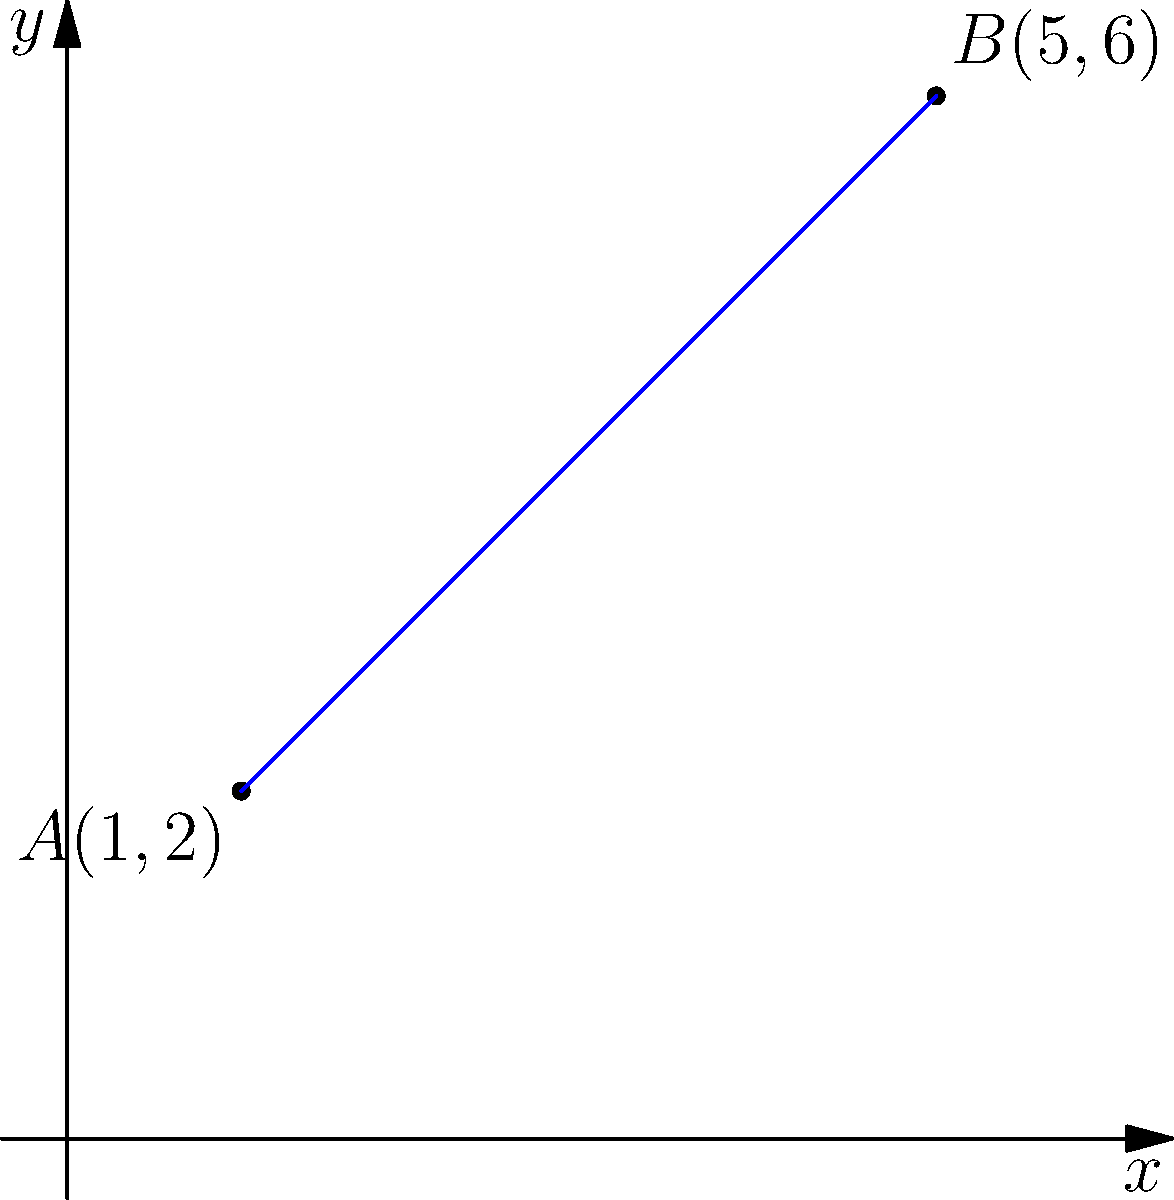In a high-profile legal case, you need to analyze the trajectory of a projectile. Two key points have been identified: point A(1,2) and point B(5,6). Determine the slope of the line passing through these points and formulate its equation in point-slope form. How would this information strengthen your case preparation? To solve this problem, we'll follow these steps:

1. Calculate the slope of the line:
   The slope formula is $m = \frac{y_2 - y_1}{x_2 - x_1}$
   
   $m = \frac{6 - 2}{5 - 1} = \frac{4}{4} = 1$

2. Use the point-slope form of a line:
   The general form is $y - y_1 = m(x - x_1)$
   
   We can use either point. Let's use A(1,2):
   
   $y - 2 = 1(x - 1)$

3. Simplify the equation:
   $y - 2 = x - 1$
   
   This is the point-slope form of the line equation.

This information strengthens the case preparation by:
a) Providing a precise mathematical model of the projectile's path
b) Allowing for accurate predictions of the projectile's position at any given point
c) Enabling the lawyer to challenge or support expert testimony regarding the trajectory
d) Facilitating clear and convincing visual representations for the jury
Answer: Slope: 1; Equation: $y - 2 = x - 1$ 